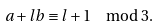Convert formula to latex. <formula><loc_0><loc_0><loc_500><loc_500>a + l b \equiv l + 1 \mod 3 .</formula> 